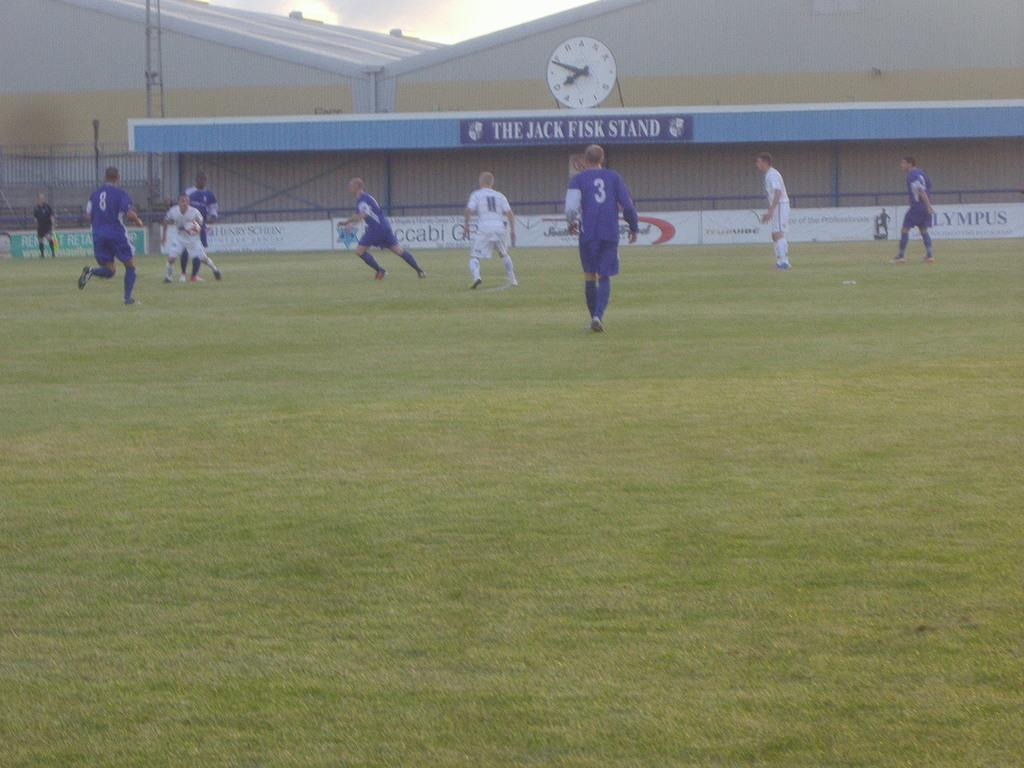<image>
Create a compact narrative representing the image presented. A team wearing blue uniforms plays soccer against a team wearing white uniforms in front of the Jack Frisk Stand. 